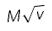Convert formula to latex. <formula><loc_0><loc_0><loc_500><loc_500>M \sqrt { v }</formula> 